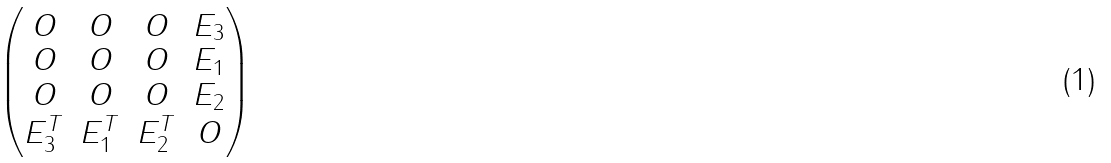<formula> <loc_0><loc_0><loc_500><loc_500>\begin{pmatrix} O & O & O & E _ { 3 } \\ O & O & O & E _ { 1 } \\ O & O & O & E _ { 2 } \\ E _ { 3 } ^ { T } & E _ { 1 } ^ { T } & E _ { 2 } ^ { T } & O \end{pmatrix}</formula> 